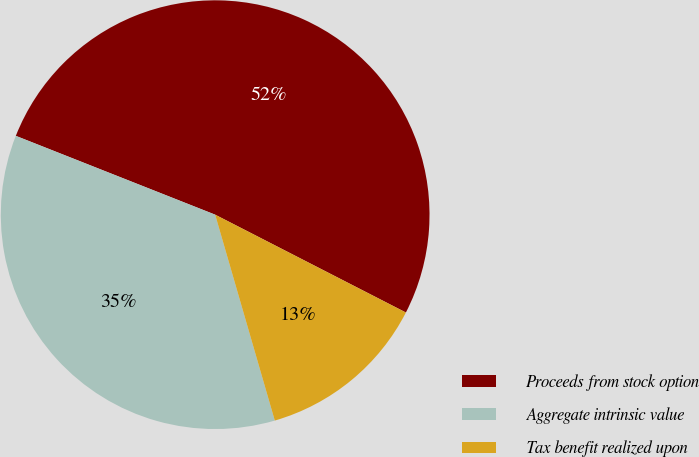Convert chart to OTSL. <chart><loc_0><loc_0><loc_500><loc_500><pie_chart><fcel>Proceeds from stock option<fcel>Aggregate intrinsic value<fcel>Tax benefit realized upon<nl><fcel>51.55%<fcel>35.48%<fcel>12.97%<nl></chart> 